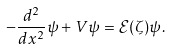Convert formula to latex. <formula><loc_0><loc_0><loc_500><loc_500>- \frac { d ^ { 2 } } { d x ^ { 2 } } \psi + V \psi = { \mathcal { E } } ( \zeta ) \psi .</formula> 